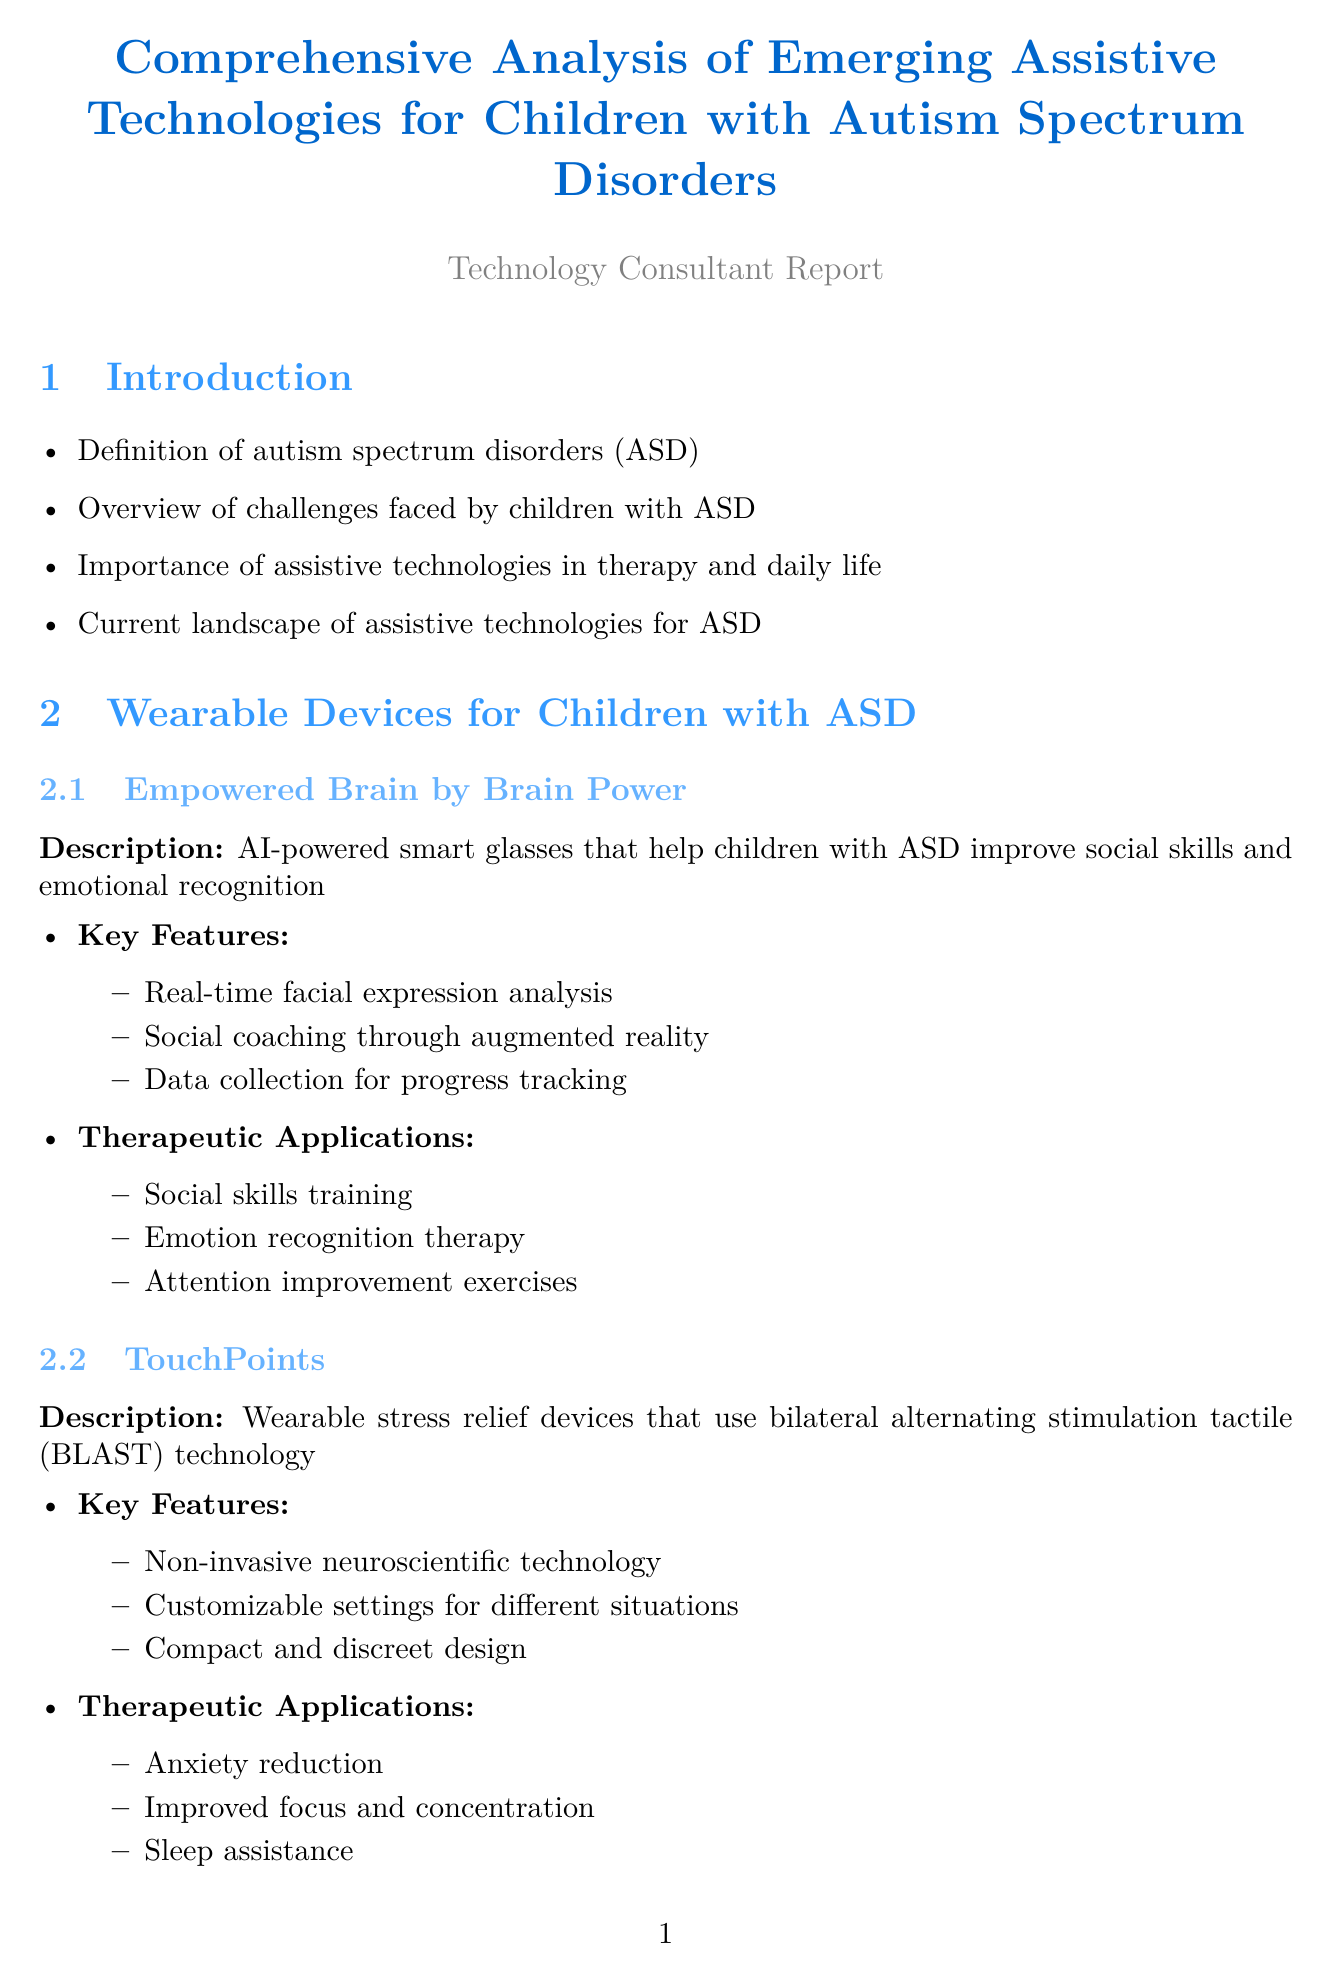What are the wearable devices discussed for children with ASD? The document lists two wearable devices for children with ASD: Empowered Brain by Brain Power and TouchPoints.
Answer: Empowered Brain, TouchPoints What is the main benefit of TouchPoints? The description states that TouchPoints are wearable stress relief devices that use bilateral alternating stimulation tactile technology.
Answer: Anxiety reduction What therapeutic application is associated with Mightier? The Mightier app focuses on helping children learn emotional regulation skills through bioresponsive video games.
Answer: Emotional regulation training Which AI-powered app is designed for non-verbal children with ASD? The document specifies Proloquo2Go as the AAC app for non-verbal children.
Answer: Proloquo2Go What emerging trend involves immersive environments for therapy? The report describes Virtual Reality Therapy as an emerging trend for social skills training.
Answer: Virtual Reality Therapy What are the implementation strategies for therapists? The document outlines various strategies, including assessing individual needs and selecting appropriate technologies.
Answer: Assessing individual needs How does machine learning contribute to ASD therapy? The report mentions that machine learning is used to analyze data and customize therapy plans.
Answer: Customize therapy plans What is a challenge related to new technologies in therapy? The document highlights several challenges, including the cost and accessibility of emerging technologies.
Answer: Cost and accessibility What is the predicted impact of advancements in assistive technologies? The future outlook section suggests that advancements will affect therapy outcomes and quality of life.
Answer: Therapy outcomes and quality of life 